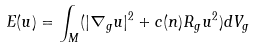Convert formula to latex. <formula><loc_0><loc_0><loc_500><loc_500>E ( u ) = \int _ { M } ( | \nabla _ { g } u | ^ { 2 } + c ( n ) R _ { g } u ^ { 2 } ) d V _ { g }</formula> 